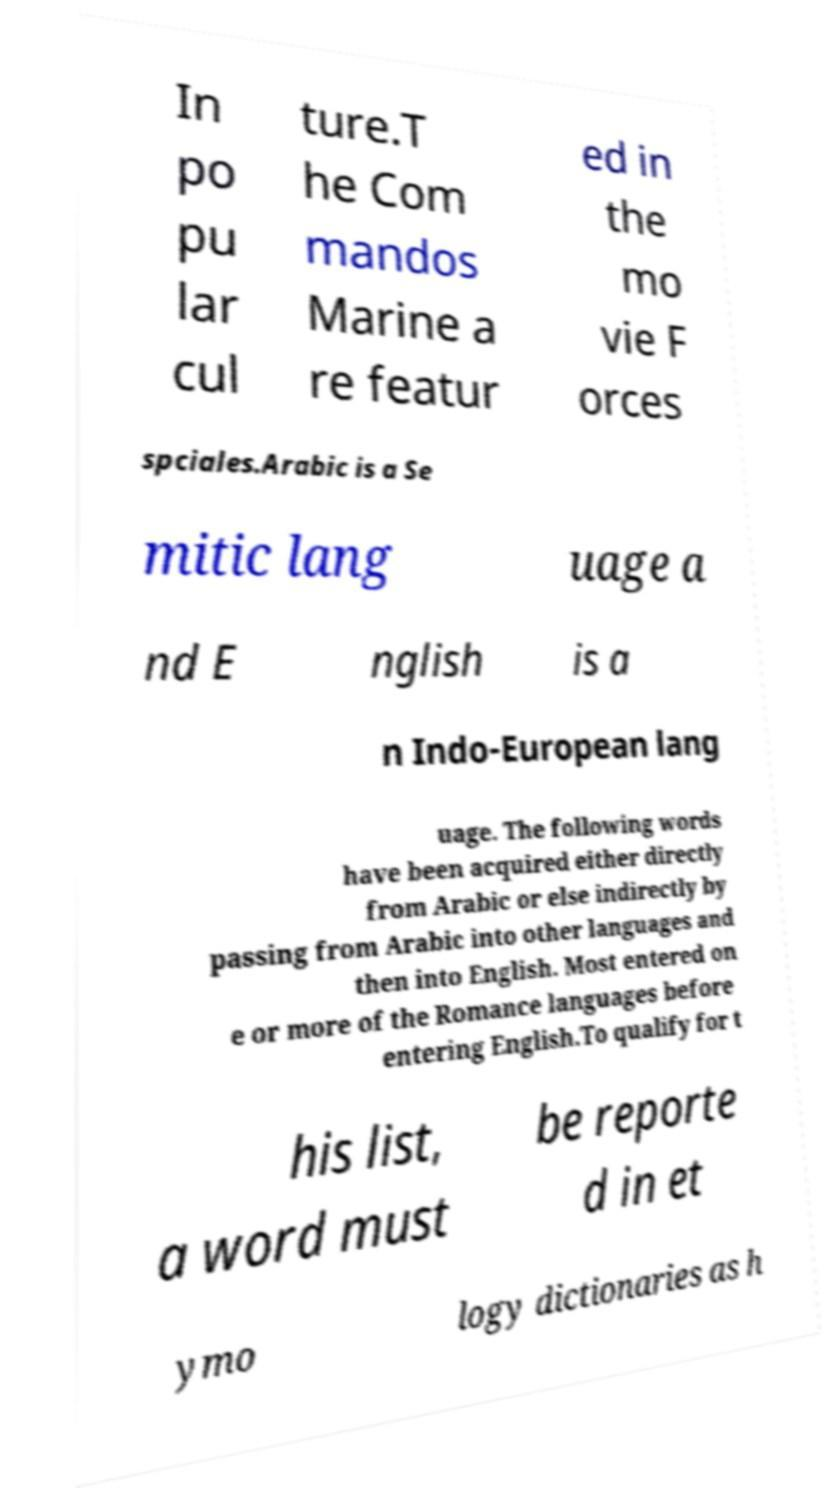Can you read and provide the text displayed in the image?This photo seems to have some interesting text. Can you extract and type it out for me? In po pu lar cul ture.T he Com mandos Marine a re featur ed in the mo vie F orces spciales.Arabic is a Se mitic lang uage a nd E nglish is a n Indo-European lang uage. The following words have been acquired either directly from Arabic or else indirectly by passing from Arabic into other languages and then into English. Most entered on e or more of the Romance languages before entering English.To qualify for t his list, a word must be reporte d in et ymo logy dictionaries as h 